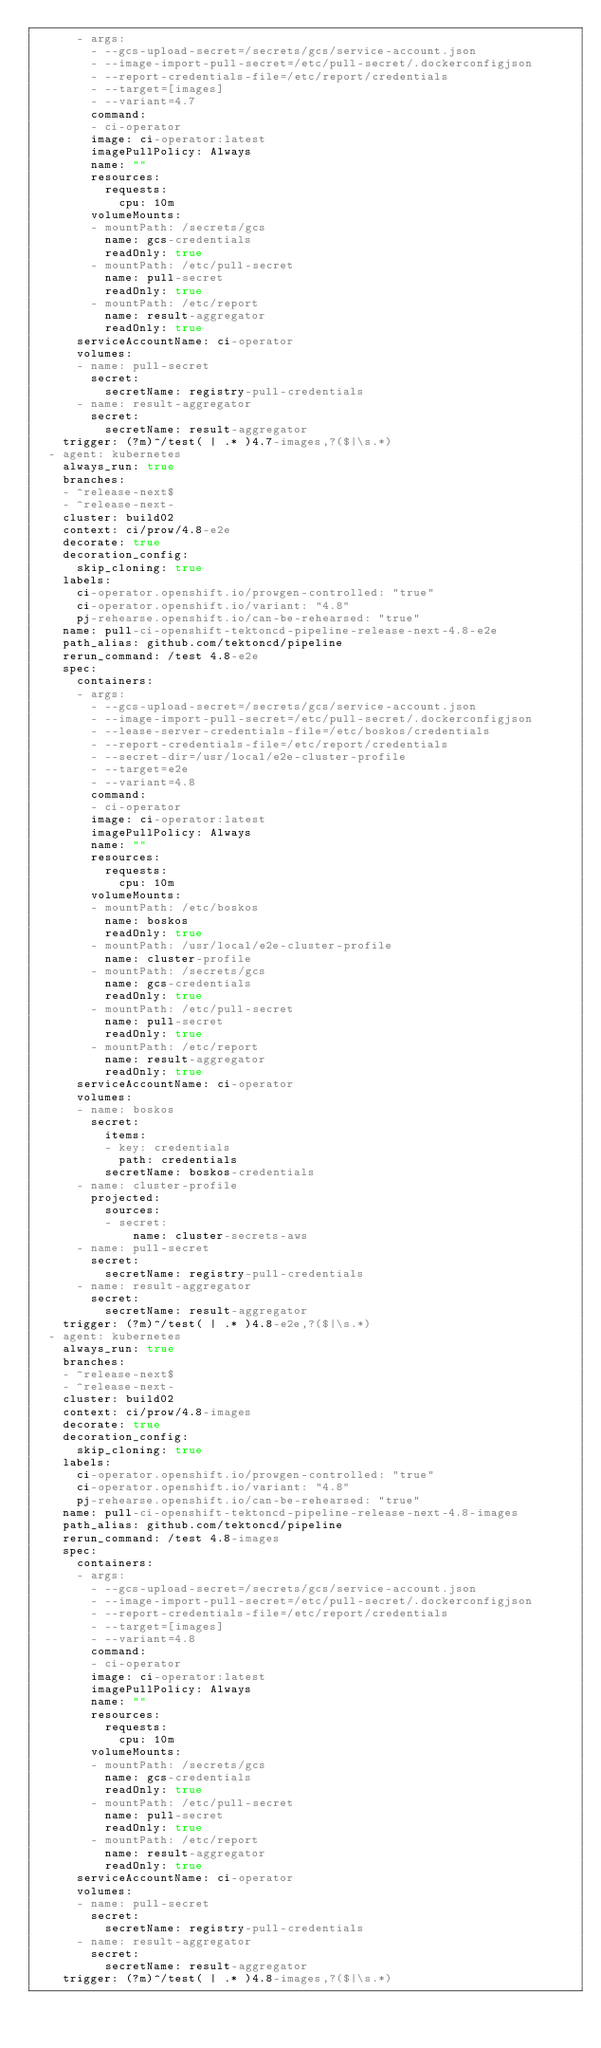Convert code to text. <code><loc_0><loc_0><loc_500><loc_500><_YAML_>      - args:
        - --gcs-upload-secret=/secrets/gcs/service-account.json
        - --image-import-pull-secret=/etc/pull-secret/.dockerconfigjson
        - --report-credentials-file=/etc/report/credentials
        - --target=[images]
        - --variant=4.7
        command:
        - ci-operator
        image: ci-operator:latest
        imagePullPolicy: Always
        name: ""
        resources:
          requests:
            cpu: 10m
        volumeMounts:
        - mountPath: /secrets/gcs
          name: gcs-credentials
          readOnly: true
        - mountPath: /etc/pull-secret
          name: pull-secret
          readOnly: true
        - mountPath: /etc/report
          name: result-aggregator
          readOnly: true
      serviceAccountName: ci-operator
      volumes:
      - name: pull-secret
        secret:
          secretName: registry-pull-credentials
      - name: result-aggregator
        secret:
          secretName: result-aggregator
    trigger: (?m)^/test( | .* )4.7-images,?($|\s.*)
  - agent: kubernetes
    always_run: true
    branches:
    - ^release-next$
    - ^release-next-
    cluster: build02
    context: ci/prow/4.8-e2e
    decorate: true
    decoration_config:
      skip_cloning: true
    labels:
      ci-operator.openshift.io/prowgen-controlled: "true"
      ci-operator.openshift.io/variant: "4.8"
      pj-rehearse.openshift.io/can-be-rehearsed: "true"
    name: pull-ci-openshift-tektoncd-pipeline-release-next-4.8-e2e
    path_alias: github.com/tektoncd/pipeline
    rerun_command: /test 4.8-e2e
    spec:
      containers:
      - args:
        - --gcs-upload-secret=/secrets/gcs/service-account.json
        - --image-import-pull-secret=/etc/pull-secret/.dockerconfigjson
        - --lease-server-credentials-file=/etc/boskos/credentials
        - --report-credentials-file=/etc/report/credentials
        - --secret-dir=/usr/local/e2e-cluster-profile
        - --target=e2e
        - --variant=4.8
        command:
        - ci-operator
        image: ci-operator:latest
        imagePullPolicy: Always
        name: ""
        resources:
          requests:
            cpu: 10m
        volumeMounts:
        - mountPath: /etc/boskos
          name: boskos
          readOnly: true
        - mountPath: /usr/local/e2e-cluster-profile
          name: cluster-profile
        - mountPath: /secrets/gcs
          name: gcs-credentials
          readOnly: true
        - mountPath: /etc/pull-secret
          name: pull-secret
          readOnly: true
        - mountPath: /etc/report
          name: result-aggregator
          readOnly: true
      serviceAccountName: ci-operator
      volumes:
      - name: boskos
        secret:
          items:
          - key: credentials
            path: credentials
          secretName: boskos-credentials
      - name: cluster-profile
        projected:
          sources:
          - secret:
              name: cluster-secrets-aws
      - name: pull-secret
        secret:
          secretName: registry-pull-credentials
      - name: result-aggregator
        secret:
          secretName: result-aggregator
    trigger: (?m)^/test( | .* )4.8-e2e,?($|\s.*)
  - agent: kubernetes
    always_run: true
    branches:
    - ^release-next$
    - ^release-next-
    cluster: build02
    context: ci/prow/4.8-images
    decorate: true
    decoration_config:
      skip_cloning: true
    labels:
      ci-operator.openshift.io/prowgen-controlled: "true"
      ci-operator.openshift.io/variant: "4.8"
      pj-rehearse.openshift.io/can-be-rehearsed: "true"
    name: pull-ci-openshift-tektoncd-pipeline-release-next-4.8-images
    path_alias: github.com/tektoncd/pipeline
    rerun_command: /test 4.8-images
    spec:
      containers:
      - args:
        - --gcs-upload-secret=/secrets/gcs/service-account.json
        - --image-import-pull-secret=/etc/pull-secret/.dockerconfigjson
        - --report-credentials-file=/etc/report/credentials
        - --target=[images]
        - --variant=4.8
        command:
        - ci-operator
        image: ci-operator:latest
        imagePullPolicy: Always
        name: ""
        resources:
          requests:
            cpu: 10m
        volumeMounts:
        - mountPath: /secrets/gcs
          name: gcs-credentials
          readOnly: true
        - mountPath: /etc/pull-secret
          name: pull-secret
          readOnly: true
        - mountPath: /etc/report
          name: result-aggregator
          readOnly: true
      serviceAccountName: ci-operator
      volumes:
      - name: pull-secret
        secret:
          secretName: registry-pull-credentials
      - name: result-aggregator
        secret:
          secretName: result-aggregator
    trigger: (?m)^/test( | .* )4.8-images,?($|\s.*)
</code> 